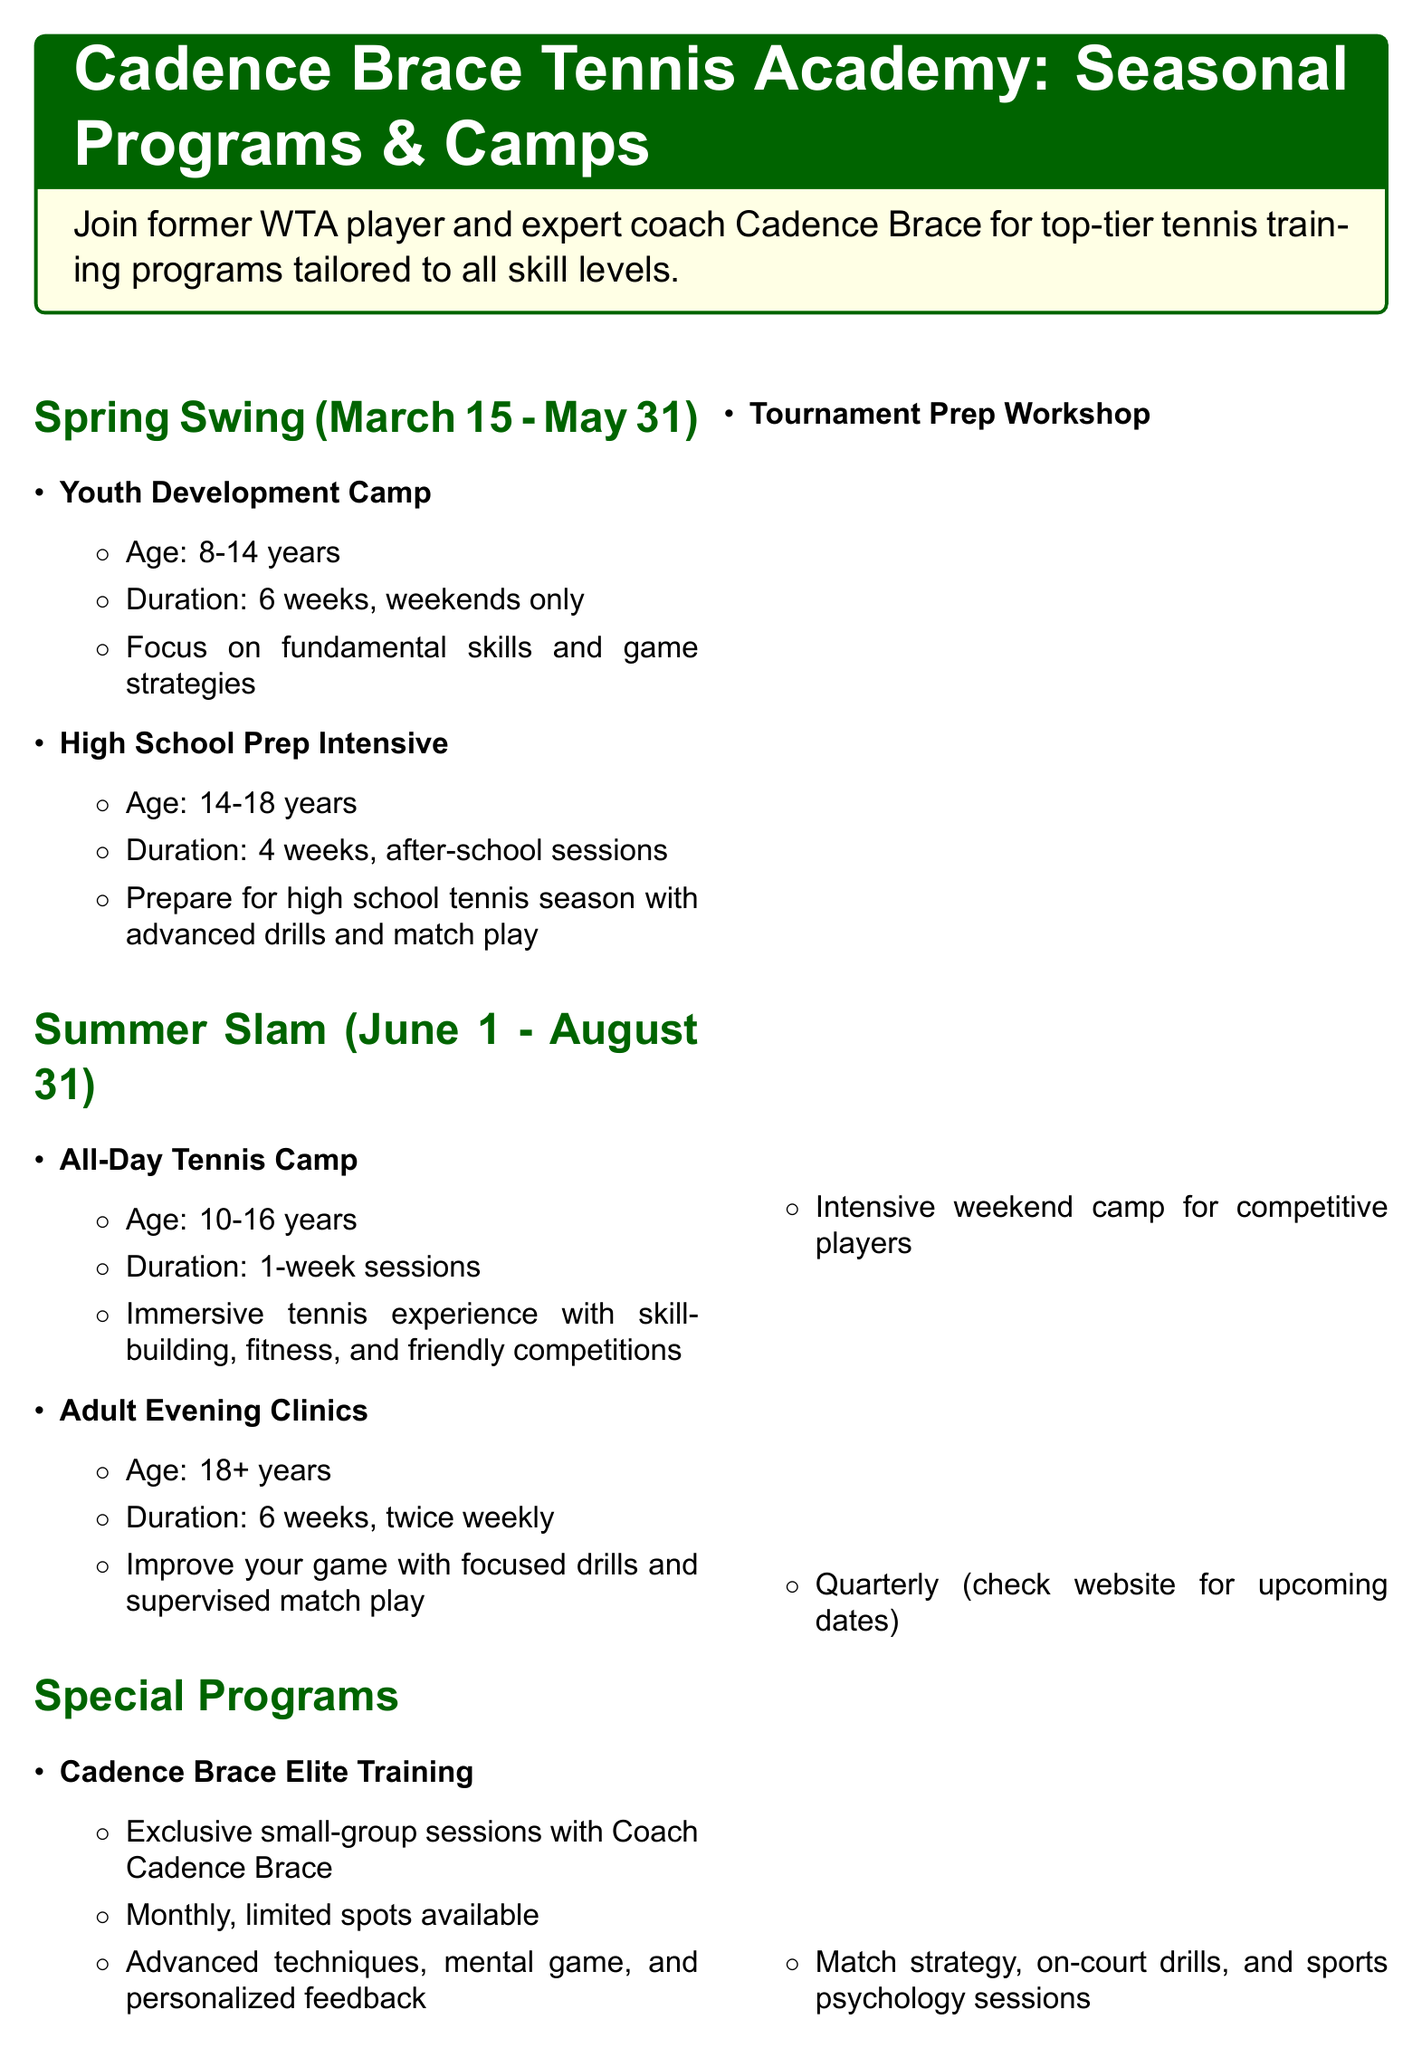what is the age range for the Youth Development Camp? The document lists the age for the Youth Development Camp as 8-14 years.
Answer: 8-14 years how long does the All-Day Tennis Camp run? According to the document, the All-Day Tennis Camp is offered in 1-week sessions.
Answer: 1-week sessions what is the focus of the High School Prep Intensive? The focus for the High School Prep Intensive includes advanced drills and match play to prepare for high school tennis season.
Answer: Advanced drills and match play how many indoor courts are available at the facilities? The document states there are 4 indoor climate-controlled courts available at the academy.
Answer: 4 indoor courts when does the Spring Swing program start? The document indicates that the Spring Swing program starts on March 15.
Answer: March 15 how often are the Cadence Brace Elite Training sessions held? The document specifies that Cadence Brace Elite Training sessions are held monthly.
Answer: Monthly what is the duration of the Adult Evening Clinics? The duration of the Adult Evening Clinics is stated to be 6 weeks, twice weekly.
Answer: 6 weeks what types of players is the Tournament Prep Workshop designed for? The document specifies that the Tournament Prep Workshop is targeted at competitive players.
Answer: Competitive players how many outdoor hard courts are there? The document mentions that there are 6 outdoor hard courts available.
Answer: 6 outdoor hard courts 